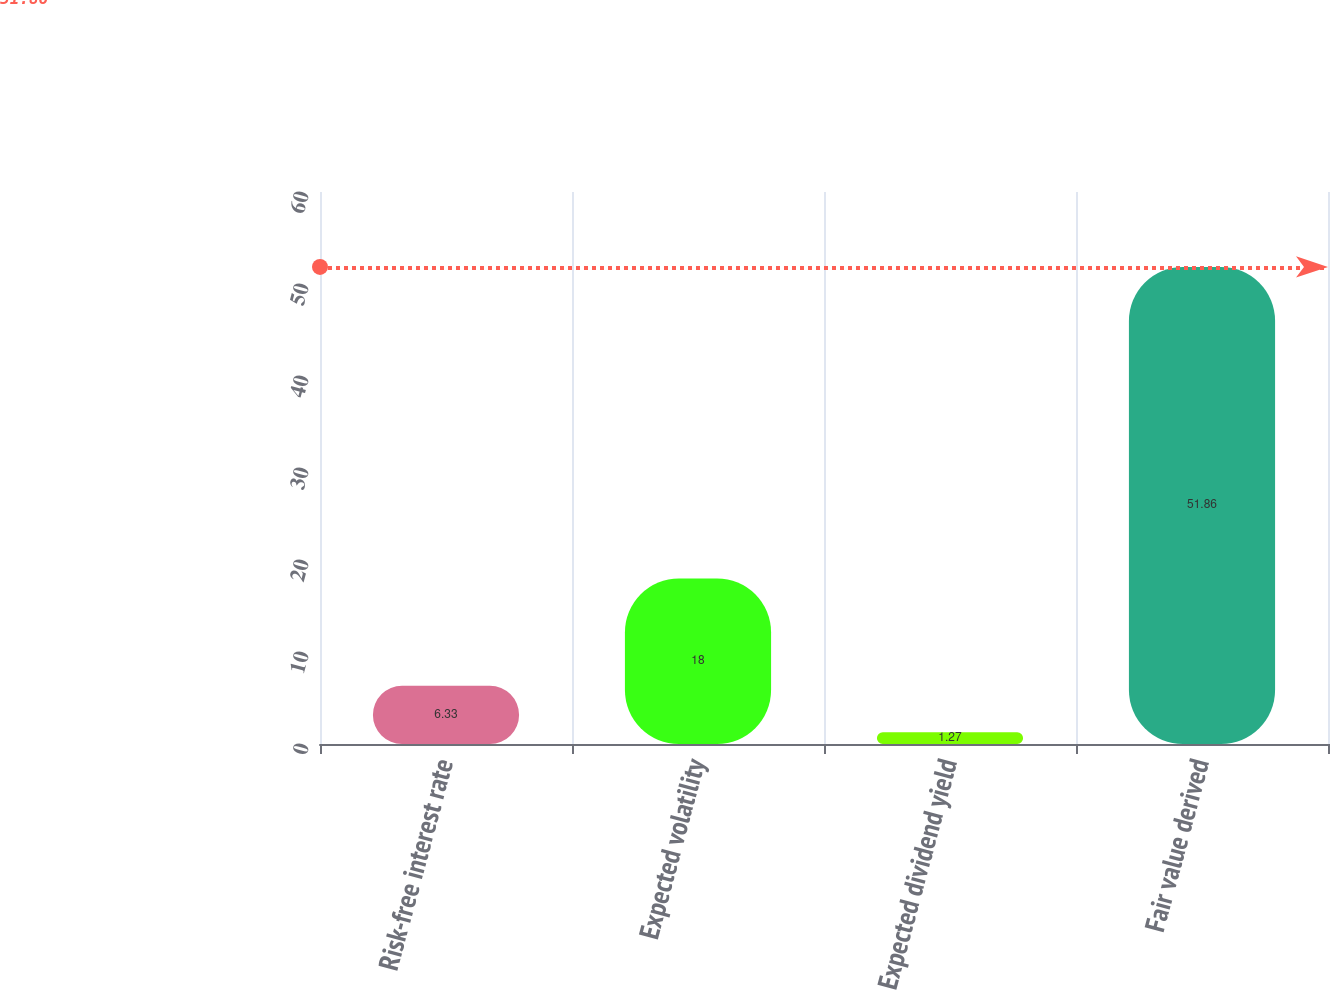<chart> <loc_0><loc_0><loc_500><loc_500><bar_chart><fcel>Risk-free interest rate<fcel>Expected volatility<fcel>Expected dividend yield<fcel>Fair value derived<nl><fcel>6.33<fcel>18<fcel>1.27<fcel>51.86<nl></chart> 